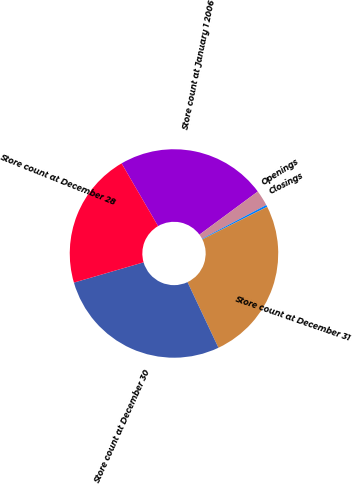<chart> <loc_0><loc_0><loc_500><loc_500><pie_chart><fcel>Store count at January 1 2006<fcel>Openings<fcel>Closings<fcel>Store count at December 31<fcel>Store count at December 30<fcel>Store count at December 28<nl><fcel>23.25%<fcel>2.44%<fcel>0.31%<fcel>25.37%<fcel>27.5%<fcel>21.12%<nl></chart> 